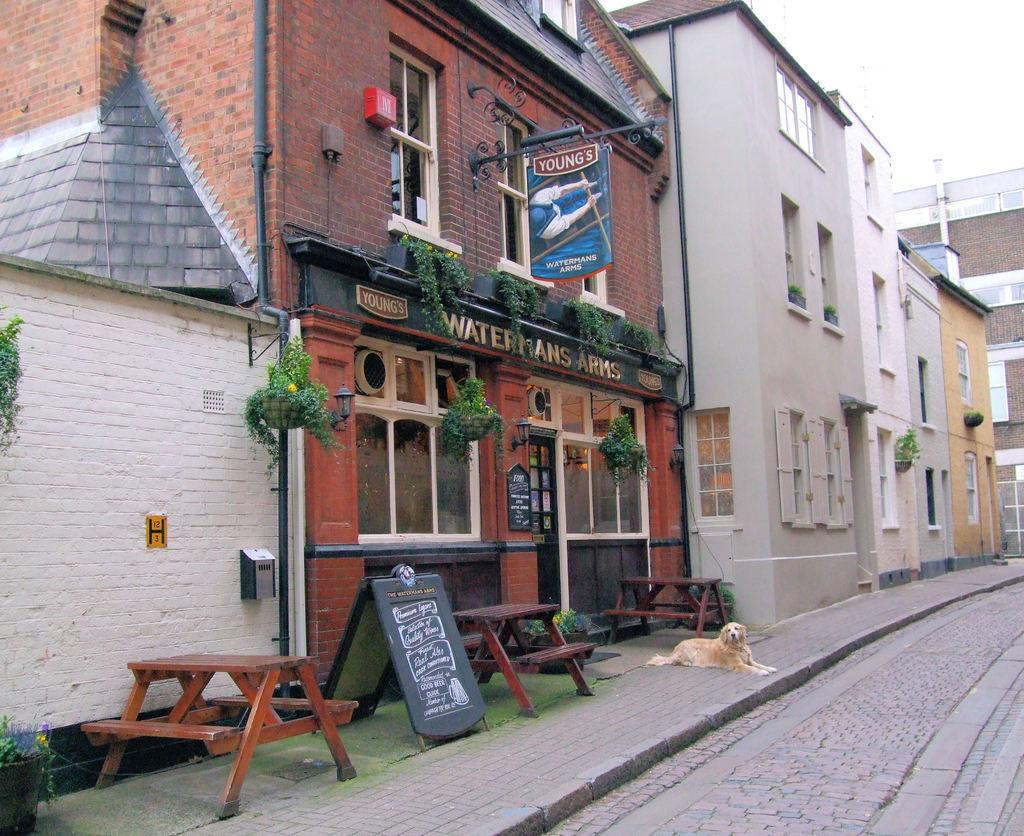What type of structures can be seen in the image? There are buildings with windows in the image. What natural elements are present in the image? There are trees in the image. What additional feature can be seen in the image? There is a banner in the image. Can you describe the surroundings in the image? There is a wall, benches, a pipe, and a flower pot in the image. What is visible in the sky in the image? The sky is visible in the image. What pathway is present in the image? There is a path in the image. Is there any animal visible in the image? Yes, there is a dog on the footpath in the image. What architectural element can be seen in the image? There is a door in the image. What test is the dog taking in the image? There is no test being taken in the image; it simply shows a dog on the footpath. What type of sun is visible in the image? There is no sun present in the image; only the sky is visible. 